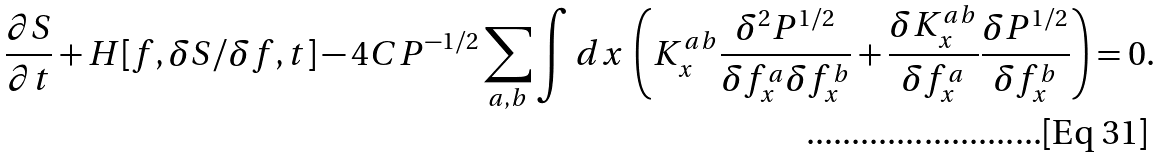<formula> <loc_0><loc_0><loc_500><loc_500>\frac { \partial S } { \partial t } + H [ f , \delta S / \delta f , t ] - 4 C P ^ { - 1 / 2 } \sum _ { a , b } \int d x \, \left ( K ^ { a b } _ { x } \frac { \delta ^ { 2 } P ^ { 1 / 2 } } { \delta f ^ { a } _ { x } \delta f ^ { b } _ { x } } + \frac { \delta K ^ { a b } _ { x } } { \delta f ^ { a } _ { x } } \frac { \delta P ^ { 1 / 2 } } { \delta f ^ { b } _ { x } } \right ) = 0 .</formula> 